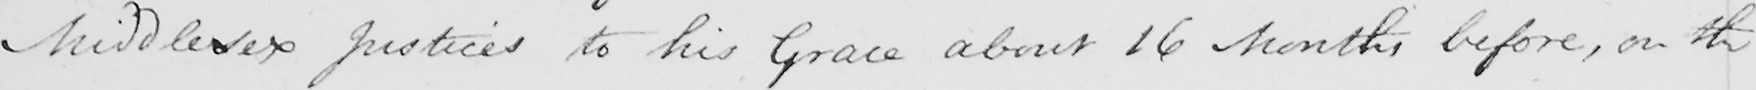Can you tell me what this handwritten text says? Middlesex Justices to his Grace about 16 Months before , on the 